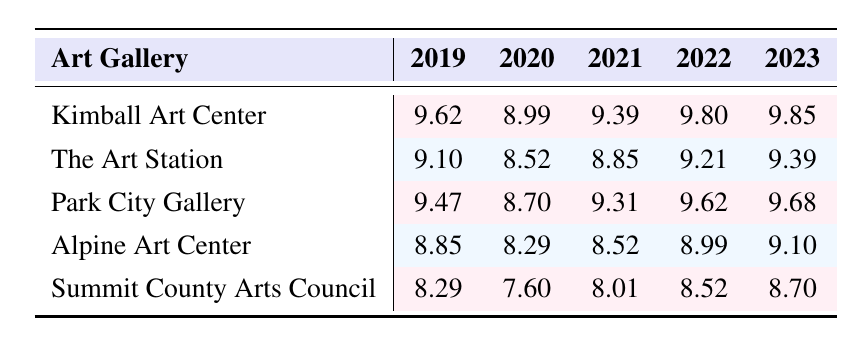What was the attendance at the Kimball Art Center in 2023? The attendance for the Kimball Art Center in 2023 is directly listed in the table under that year, which shows 19000 visitors.
Answer: 19000 Which art gallery had the lowest attendance in 2020? Looking at the attendance values for 2020 across all galleries, the Summit County Arts Council has the lowest figure listed, which is 2000.
Answer: 2000 What is the average attendance for Park City Gallery over the five years? To find the average, first sum the attendance values for each year: (13000 + 6000 + 11000 + 15000 + 16000) = 61000. Then divide this total by the number of years, which is 5: 61000 / 5 = 12200.
Answer: 12200 Did the attendance at The Art Station increase from 2020 to 2023? Comparing the attendance figures for The Art Station in 2020 (5000) with that in 2023 (12000), there is an increase as 12000 is greater than 5000.
Answer: Yes Which gallery had the highest total attendance over the last five years? First, sum the attendance for each gallery across all years. Kimball Art Center: 15000 + 8000 + 12000 + 18000 + 19000 = 62000; The Art Station: 9000 + 5000 + 7000 + 10000 + 12000 = 44000; Park City Gallery: 13000 + 6000 + 11000 + 15000 + 16000 = 61000; Alpine Art Center: 7000 + 4000 + 5000 + 8000 + 9000 = 33000; Summit County Arts Council: 4000 + 2000 + 3000 + 5000 + 6000 = 20000. The highest total is from Kimball Art Center with 62000.
Answer: Kimball Art Center What was the change in attendance from 2019 to 2022 for the Alpine Art Center? The attendance in 2019 was 7000, and in 2022 it was 8000. The change is calculated by subtracting the earlier year from the later year: 8000 - 7000 = 1000, indicating an increase of 1000 visitors.
Answer: 1000 Is the attendance at the Summit County Arts Council in 2022 higher than that in 2021? The attendance for Summit County Arts Council in 2022 is 5000 while for 2021 it is 3000. Since 5000 is greater than 3000, the attendance in 2022 is indeed higher.
Answer: Yes Which gallery had the second highest attendance in 2021? Looking at the 2021 attendance values, the galleries have the following numbers: Kimball Art Center (12000), Park City Gallery (11000), The Art Station (7000), Alpine Art Center (5000), and Summit County Arts Council (3000). The second highest is Park City Gallery with 11000.
Answer: Park City Gallery 